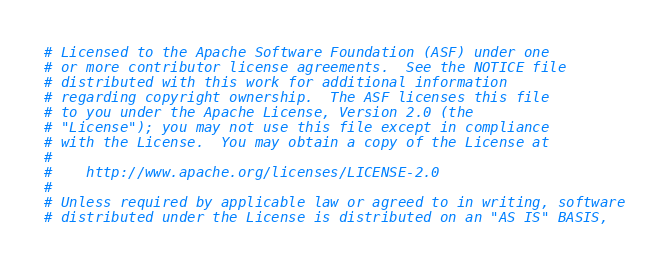<code> <loc_0><loc_0><loc_500><loc_500><_YAML_># Licensed to the Apache Software Foundation (ASF) under one
# or more contributor license agreements.  See the NOTICE file
# distributed with this work for additional information
# regarding copyright ownership.  The ASF licenses this file
# to you under the Apache License, Version 2.0 (the
# "License"); you may not use this file except in compliance
# with the License.  You may obtain a copy of the License at
#
#    http://www.apache.org/licenses/LICENSE-2.0
#
# Unless required by applicable law or agreed to in writing, software
# distributed under the License is distributed on an "AS IS" BASIS,</code> 